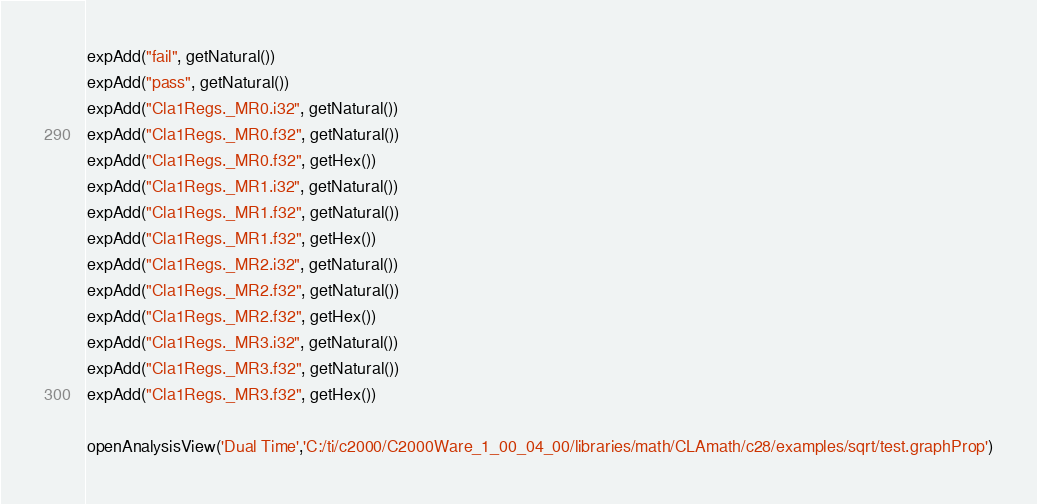Convert code to text. <code><loc_0><loc_0><loc_500><loc_500><_JavaScript_>expAdd("fail", getNatural())
expAdd("pass", getNatural())
expAdd("Cla1Regs._MR0.i32", getNatural())
expAdd("Cla1Regs._MR0.f32", getNatural())
expAdd("Cla1Regs._MR0.f32", getHex())
expAdd("Cla1Regs._MR1.i32", getNatural())
expAdd("Cla1Regs._MR1.f32", getNatural())
expAdd("Cla1Regs._MR1.f32", getHex())
expAdd("Cla1Regs._MR2.i32", getNatural())
expAdd("Cla1Regs._MR2.f32", getNatural())
expAdd("Cla1Regs._MR2.f32", getHex())
expAdd("Cla1Regs._MR3.i32", getNatural())
expAdd("Cla1Regs._MR3.f32", getNatural())
expAdd("Cla1Regs._MR3.f32", getHex())

openAnalysisView('Dual Time','C:/ti/c2000/C2000Ware_1_00_04_00/libraries/math/CLAmath/c28/examples/sqrt/test.graphProp')
</code> 